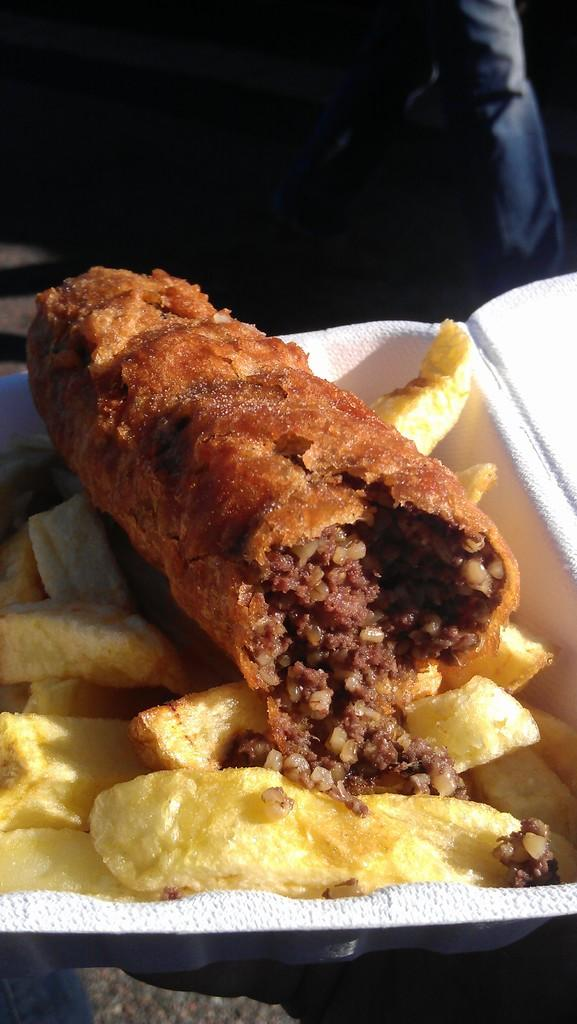What object is in the image that is white in color? There is a white box in the image. What is on top of the white box? There is food on the white box. What colors can be seen in the food? The food has yellow, red, and brown colors. What is the color of the background in the image? The background of the image is dark. Can you hear the bells ringing in the image? There are no bells present in the image, so it is not possible to hear them ringing. 